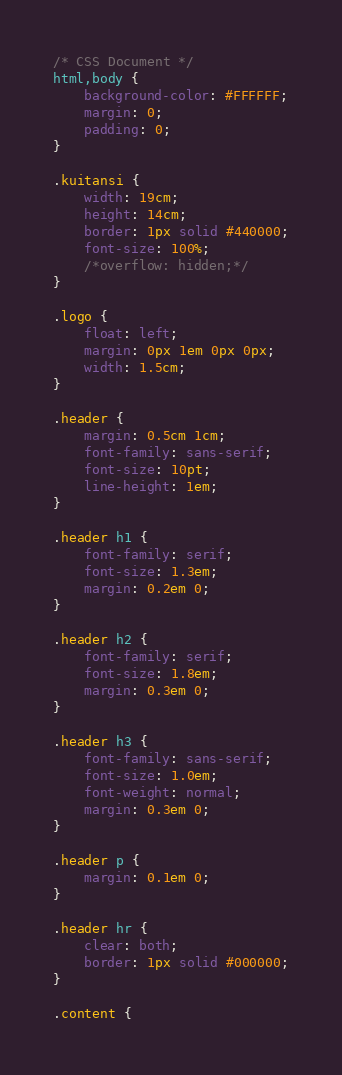<code> <loc_0><loc_0><loc_500><loc_500><_CSS_>/* CSS Document */
html,body {
	background-color: #FFFFFF;
	margin: 0;
	padding: 0;
}

.kuitansi {
	width: 19cm;
	height: 14cm;
	border: 1px solid #440000;
	font-size: 100%;
	/*overflow: hidden;*/
}

.logo {
	float: left;
	margin: 0px 1em 0px 0px;
	width: 1.5cm;
}

.header {
	margin: 0.5cm 1cm;
	font-family: sans-serif;
	font-size: 10pt;
	line-height: 1em;
}

.header h1 {
	font-family: serif;
	font-size: 1.3em;
	margin: 0.2em 0;
}

.header h2 {
	font-family: serif;
	font-size: 1.8em;
	margin: 0.3em 0;
}

.header h3 {
	font-family: sans-serif;
	font-size: 1.0em;
	font-weight: normal;
	margin: 0.3em 0;
}

.header p {
	margin: 0.1em 0;
} 

.header hr {
	clear: both;
	border: 1px solid #000000;
}

.content {</code> 